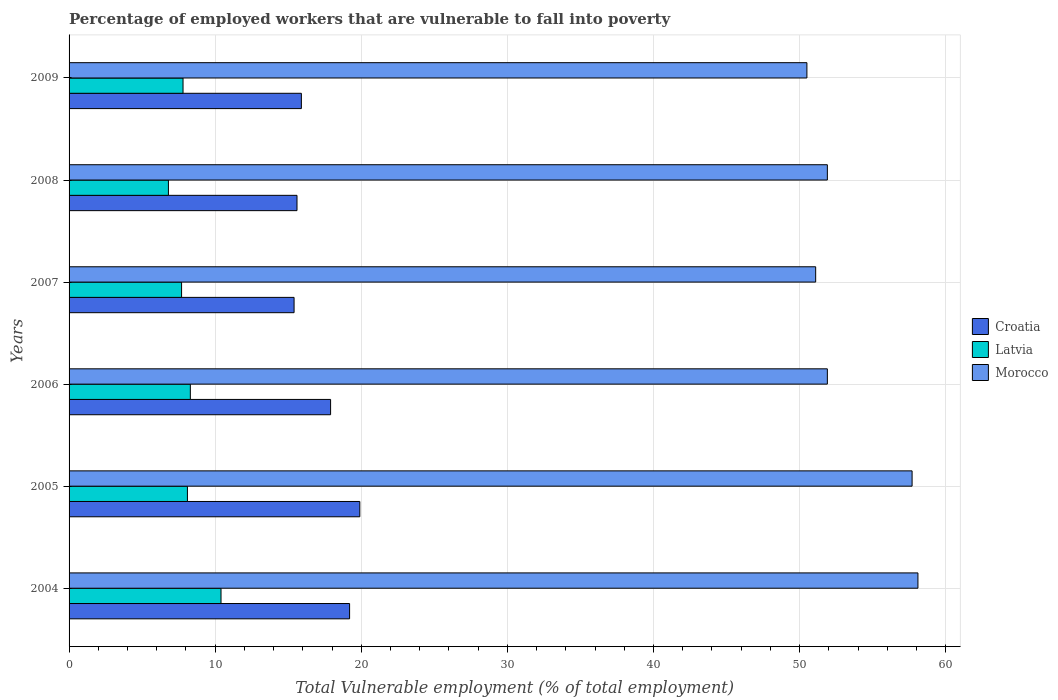Are the number of bars per tick equal to the number of legend labels?
Your response must be concise. Yes. Are the number of bars on each tick of the Y-axis equal?
Your answer should be compact. Yes. How many bars are there on the 4th tick from the top?
Offer a terse response. 3. How many bars are there on the 2nd tick from the bottom?
Make the answer very short. 3. What is the percentage of employed workers who are vulnerable to fall into poverty in Croatia in 2005?
Your answer should be compact. 19.9. Across all years, what is the maximum percentage of employed workers who are vulnerable to fall into poverty in Latvia?
Your answer should be compact. 10.4. Across all years, what is the minimum percentage of employed workers who are vulnerable to fall into poverty in Latvia?
Your response must be concise. 6.8. In which year was the percentage of employed workers who are vulnerable to fall into poverty in Morocco maximum?
Your answer should be compact. 2004. What is the total percentage of employed workers who are vulnerable to fall into poverty in Latvia in the graph?
Give a very brief answer. 49.1. What is the difference between the percentage of employed workers who are vulnerable to fall into poverty in Morocco in 2006 and that in 2007?
Offer a very short reply. 0.8. What is the difference between the percentage of employed workers who are vulnerable to fall into poverty in Croatia in 2004 and the percentage of employed workers who are vulnerable to fall into poverty in Latvia in 2005?
Provide a short and direct response. 11.1. What is the average percentage of employed workers who are vulnerable to fall into poverty in Latvia per year?
Provide a short and direct response. 8.18. In the year 2006, what is the difference between the percentage of employed workers who are vulnerable to fall into poverty in Croatia and percentage of employed workers who are vulnerable to fall into poverty in Latvia?
Give a very brief answer. 9.6. What is the ratio of the percentage of employed workers who are vulnerable to fall into poverty in Latvia in 2004 to that in 2006?
Give a very brief answer. 1.25. Is the difference between the percentage of employed workers who are vulnerable to fall into poverty in Croatia in 2006 and 2008 greater than the difference between the percentage of employed workers who are vulnerable to fall into poverty in Latvia in 2006 and 2008?
Your answer should be compact. Yes. What is the difference between the highest and the second highest percentage of employed workers who are vulnerable to fall into poverty in Latvia?
Offer a terse response. 2.1. What is the difference between the highest and the lowest percentage of employed workers who are vulnerable to fall into poverty in Morocco?
Offer a very short reply. 7.6. In how many years, is the percentage of employed workers who are vulnerable to fall into poverty in Latvia greater than the average percentage of employed workers who are vulnerable to fall into poverty in Latvia taken over all years?
Give a very brief answer. 2. What does the 2nd bar from the top in 2005 represents?
Keep it short and to the point. Latvia. What does the 2nd bar from the bottom in 2006 represents?
Your answer should be compact. Latvia. Is it the case that in every year, the sum of the percentage of employed workers who are vulnerable to fall into poverty in Latvia and percentage of employed workers who are vulnerable to fall into poverty in Morocco is greater than the percentage of employed workers who are vulnerable to fall into poverty in Croatia?
Your answer should be very brief. Yes. How many bars are there?
Offer a very short reply. 18. Are all the bars in the graph horizontal?
Provide a succinct answer. Yes. Are the values on the major ticks of X-axis written in scientific E-notation?
Give a very brief answer. No. How are the legend labels stacked?
Ensure brevity in your answer.  Vertical. What is the title of the graph?
Keep it short and to the point. Percentage of employed workers that are vulnerable to fall into poverty. Does "East Asia (all income levels)" appear as one of the legend labels in the graph?
Your answer should be compact. No. What is the label or title of the X-axis?
Provide a succinct answer. Total Vulnerable employment (% of total employment). What is the label or title of the Y-axis?
Provide a succinct answer. Years. What is the Total Vulnerable employment (% of total employment) of Croatia in 2004?
Offer a terse response. 19.2. What is the Total Vulnerable employment (% of total employment) of Latvia in 2004?
Give a very brief answer. 10.4. What is the Total Vulnerable employment (% of total employment) of Morocco in 2004?
Keep it short and to the point. 58.1. What is the Total Vulnerable employment (% of total employment) of Croatia in 2005?
Your answer should be very brief. 19.9. What is the Total Vulnerable employment (% of total employment) in Latvia in 2005?
Offer a very short reply. 8.1. What is the Total Vulnerable employment (% of total employment) of Morocco in 2005?
Offer a very short reply. 57.7. What is the Total Vulnerable employment (% of total employment) of Croatia in 2006?
Keep it short and to the point. 17.9. What is the Total Vulnerable employment (% of total employment) of Latvia in 2006?
Your answer should be very brief. 8.3. What is the Total Vulnerable employment (% of total employment) of Morocco in 2006?
Provide a short and direct response. 51.9. What is the Total Vulnerable employment (% of total employment) in Croatia in 2007?
Give a very brief answer. 15.4. What is the Total Vulnerable employment (% of total employment) in Latvia in 2007?
Offer a very short reply. 7.7. What is the Total Vulnerable employment (% of total employment) in Morocco in 2007?
Ensure brevity in your answer.  51.1. What is the Total Vulnerable employment (% of total employment) of Croatia in 2008?
Provide a succinct answer. 15.6. What is the Total Vulnerable employment (% of total employment) of Latvia in 2008?
Offer a very short reply. 6.8. What is the Total Vulnerable employment (% of total employment) of Morocco in 2008?
Give a very brief answer. 51.9. What is the Total Vulnerable employment (% of total employment) in Croatia in 2009?
Your answer should be very brief. 15.9. What is the Total Vulnerable employment (% of total employment) of Latvia in 2009?
Offer a very short reply. 7.8. What is the Total Vulnerable employment (% of total employment) of Morocco in 2009?
Give a very brief answer. 50.5. Across all years, what is the maximum Total Vulnerable employment (% of total employment) in Croatia?
Keep it short and to the point. 19.9. Across all years, what is the maximum Total Vulnerable employment (% of total employment) of Latvia?
Keep it short and to the point. 10.4. Across all years, what is the maximum Total Vulnerable employment (% of total employment) of Morocco?
Your answer should be very brief. 58.1. Across all years, what is the minimum Total Vulnerable employment (% of total employment) of Croatia?
Your answer should be very brief. 15.4. Across all years, what is the minimum Total Vulnerable employment (% of total employment) of Latvia?
Make the answer very short. 6.8. Across all years, what is the minimum Total Vulnerable employment (% of total employment) in Morocco?
Provide a succinct answer. 50.5. What is the total Total Vulnerable employment (% of total employment) of Croatia in the graph?
Provide a short and direct response. 103.9. What is the total Total Vulnerable employment (% of total employment) in Latvia in the graph?
Your answer should be compact. 49.1. What is the total Total Vulnerable employment (% of total employment) of Morocco in the graph?
Your response must be concise. 321.2. What is the difference between the Total Vulnerable employment (% of total employment) of Latvia in 2004 and that in 2005?
Offer a very short reply. 2.3. What is the difference between the Total Vulnerable employment (% of total employment) in Croatia in 2004 and that in 2006?
Give a very brief answer. 1.3. What is the difference between the Total Vulnerable employment (% of total employment) in Morocco in 2004 and that in 2006?
Offer a terse response. 6.2. What is the difference between the Total Vulnerable employment (% of total employment) of Croatia in 2004 and that in 2007?
Your response must be concise. 3.8. What is the difference between the Total Vulnerable employment (% of total employment) in Latvia in 2004 and that in 2007?
Make the answer very short. 2.7. What is the difference between the Total Vulnerable employment (% of total employment) in Morocco in 2004 and that in 2007?
Provide a short and direct response. 7. What is the difference between the Total Vulnerable employment (% of total employment) of Latvia in 2004 and that in 2009?
Ensure brevity in your answer.  2.6. What is the difference between the Total Vulnerable employment (% of total employment) in Morocco in 2004 and that in 2009?
Your answer should be very brief. 7.6. What is the difference between the Total Vulnerable employment (% of total employment) of Croatia in 2005 and that in 2006?
Your response must be concise. 2. What is the difference between the Total Vulnerable employment (% of total employment) in Latvia in 2005 and that in 2006?
Your answer should be very brief. -0.2. What is the difference between the Total Vulnerable employment (% of total employment) in Croatia in 2005 and that in 2007?
Your answer should be compact. 4.5. What is the difference between the Total Vulnerable employment (% of total employment) in Latvia in 2005 and that in 2007?
Give a very brief answer. 0.4. What is the difference between the Total Vulnerable employment (% of total employment) of Morocco in 2005 and that in 2007?
Ensure brevity in your answer.  6.6. What is the difference between the Total Vulnerable employment (% of total employment) in Croatia in 2005 and that in 2009?
Ensure brevity in your answer.  4. What is the difference between the Total Vulnerable employment (% of total employment) of Morocco in 2005 and that in 2009?
Offer a terse response. 7.2. What is the difference between the Total Vulnerable employment (% of total employment) in Morocco in 2006 and that in 2007?
Give a very brief answer. 0.8. What is the difference between the Total Vulnerable employment (% of total employment) in Croatia in 2006 and that in 2008?
Your response must be concise. 2.3. What is the difference between the Total Vulnerable employment (% of total employment) of Morocco in 2006 and that in 2008?
Offer a very short reply. 0. What is the difference between the Total Vulnerable employment (% of total employment) in Croatia in 2006 and that in 2009?
Your answer should be very brief. 2. What is the difference between the Total Vulnerable employment (% of total employment) in Latvia in 2006 and that in 2009?
Keep it short and to the point. 0.5. What is the difference between the Total Vulnerable employment (% of total employment) of Croatia in 2007 and that in 2008?
Your answer should be very brief. -0.2. What is the difference between the Total Vulnerable employment (% of total employment) of Morocco in 2007 and that in 2008?
Provide a short and direct response. -0.8. What is the difference between the Total Vulnerable employment (% of total employment) of Croatia in 2007 and that in 2009?
Your answer should be very brief. -0.5. What is the difference between the Total Vulnerable employment (% of total employment) in Latvia in 2007 and that in 2009?
Your response must be concise. -0.1. What is the difference between the Total Vulnerable employment (% of total employment) in Latvia in 2008 and that in 2009?
Offer a terse response. -1. What is the difference between the Total Vulnerable employment (% of total employment) in Croatia in 2004 and the Total Vulnerable employment (% of total employment) in Morocco in 2005?
Your response must be concise. -38.5. What is the difference between the Total Vulnerable employment (% of total employment) of Latvia in 2004 and the Total Vulnerable employment (% of total employment) of Morocco in 2005?
Keep it short and to the point. -47.3. What is the difference between the Total Vulnerable employment (% of total employment) in Croatia in 2004 and the Total Vulnerable employment (% of total employment) in Latvia in 2006?
Provide a short and direct response. 10.9. What is the difference between the Total Vulnerable employment (% of total employment) in Croatia in 2004 and the Total Vulnerable employment (% of total employment) in Morocco in 2006?
Provide a short and direct response. -32.7. What is the difference between the Total Vulnerable employment (% of total employment) of Latvia in 2004 and the Total Vulnerable employment (% of total employment) of Morocco in 2006?
Give a very brief answer. -41.5. What is the difference between the Total Vulnerable employment (% of total employment) in Croatia in 2004 and the Total Vulnerable employment (% of total employment) in Latvia in 2007?
Make the answer very short. 11.5. What is the difference between the Total Vulnerable employment (% of total employment) of Croatia in 2004 and the Total Vulnerable employment (% of total employment) of Morocco in 2007?
Make the answer very short. -31.9. What is the difference between the Total Vulnerable employment (% of total employment) in Latvia in 2004 and the Total Vulnerable employment (% of total employment) in Morocco in 2007?
Ensure brevity in your answer.  -40.7. What is the difference between the Total Vulnerable employment (% of total employment) of Croatia in 2004 and the Total Vulnerable employment (% of total employment) of Morocco in 2008?
Your response must be concise. -32.7. What is the difference between the Total Vulnerable employment (% of total employment) in Latvia in 2004 and the Total Vulnerable employment (% of total employment) in Morocco in 2008?
Make the answer very short. -41.5. What is the difference between the Total Vulnerable employment (% of total employment) of Croatia in 2004 and the Total Vulnerable employment (% of total employment) of Latvia in 2009?
Your answer should be very brief. 11.4. What is the difference between the Total Vulnerable employment (% of total employment) of Croatia in 2004 and the Total Vulnerable employment (% of total employment) of Morocco in 2009?
Make the answer very short. -31.3. What is the difference between the Total Vulnerable employment (% of total employment) of Latvia in 2004 and the Total Vulnerable employment (% of total employment) of Morocco in 2009?
Ensure brevity in your answer.  -40.1. What is the difference between the Total Vulnerable employment (% of total employment) of Croatia in 2005 and the Total Vulnerable employment (% of total employment) of Latvia in 2006?
Offer a terse response. 11.6. What is the difference between the Total Vulnerable employment (% of total employment) of Croatia in 2005 and the Total Vulnerable employment (% of total employment) of Morocco in 2006?
Provide a succinct answer. -32. What is the difference between the Total Vulnerable employment (% of total employment) of Latvia in 2005 and the Total Vulnerable employment (% of total employment) of Morocco in 2006?
Make the answer very short. -43.8. What is the difference between the Total Vulnerable employment (% of total employment) of Croatia in 2005 and the Total Vulnerable employment (% of total employment) of Latvia in 2007?
Provide a short and direct response. 12.2. What is the difference between the Total Vulnerable employment (% of total employment) in Croatia in 2005 and the Total Vulnerable employment (% of total employment) in Morocco in 2007?
Ensure brevity in your answer.  -31.2. What is the difference between the Total Vulnerable employment (% of total employment) in Latvia in 2005 and the Total Vulnerable employment (% of total employment) in Morocco in 2007?
Your answer should be compact. -43. What is the difference between the Total Vulnerable employment (% of total employment) in Croatia in 2005 and the Total Vulnerable employment (% of total employment) in Morocco in 2008?
Keep it short and to the point. -32. What is the difference between the Total Vulnerable employment (% of total employment) of Latvia in 2005 and the Total Vulnerable employment (% of total employment) of Morocco in 2008?
Your answer should be very brief. -43.8. What is the difference between the Total Vulnerable employment (% of total employment) in Croatia in 2005 and the Total Vulnerable employment (% of total employment) in Latvia in 2009?
Offer a terse response. 12.1. What is the difference between the Total Vulnerable employment (% of total employment) in Croatia in 2005 and the Total Vulnerable employment (% of total employment) in Morocco in 2009?
Keep it short and to the point. -30.6. What is the difference between the Total Vulnerable employment (% of total employment) of Latvia in 2005 and the Total Vulnerable employment (% of total employment) of Morocco in 2009?
Offer a very short reply. -42.4. What is the difference between the Total Vulnerable employment (% of total employment) in Croatia in 2006 and the Total Vulnerable employment (% of total employment) in Morocco in 2007?
Offer a very short reply. -33.2. What is the difference between the Total Vulnerable employment (% of total employment) of Latvia in 2006 and the Total Vulnerable employment (% of total employment) of Morocco in 2007?
Your answer should be very brief. -42.8. What is the difference between the Total Vulnerable employment (% of total employment) in Croatia in 2006 and the Total Vulnerable employment (% of total employment) in Latvia in 2008?
Offer a terse response. 11.1. What is the difference between the Total Vulnerable employment (% of total employment) of Croatia in 2006 and the Total Vulnerable employment (% of total employment) of Morocco in 2008?
Your answer should be very brief. -34. What is the difference between the Total Vulnerable employment (% of total employment) in Latvia in 2006 and the Total Vulnerable employment (% of total employment) in Morocco in 2008?
Provide a short and direct response. -43.6. What is the difference between the Total Vulnerable employment (% of total employment) in Croatia in 2006 and the Total Vulnerable employment (% of total employment) in Latvia in 2009?
Make the answer very short. 10.1. What is the difference between the Total Vulnerable employment (% of total employment) of Croatia in 2006 and the Total Vulnerable employment (% of total employment) of Morocco in 2009?
Your answer should be very brief. -32.6. What is the difference between the Total Vulnerable employment (% of total employment) in Latvia in 2006 and the Total Vulnerable employment (% of total employment) in Morocco in 2009?
Give a very brief answer. -42.2. What is the difference between the Total Vulnerable employment (% of total employment) in Croatia in 2007 and the Total Vulnerable employment (% of total employment) in Latvia in 2008?
Your response must be concise. 8.6. What is the difference between the Total Vulnerable employment (% of total employment) of Croatia in 2007 and the Total Vulnerable employment (% of total employment) of Morocco in 2008?
Give a very brief answer. -36.5. What is the difference between the Total Vulnerable employment (% of total employment) of Latvia in 2007 and the Total Vulnerable employment (% of total employment) of Morocco in 2008?
Make the answer very short. -44.2. What is the difference between the Total Vulnerable employment (% of total employment) of Croatia in 2007 and the Total Vulnerable employment (% of total employment) of Morocco in 2009?
Your response must be concise. -35.1. What is the difference between the Total Vulnerable employment (% of total employment) in Latvia in 2007 and the Total Vulnerable employment (% of total employment) in Morocco in 2009?
Your answer should be very brief. -42.8. What is the difference between the Total Vulnerable employment (% of total employment) of Croatia in 2008 and the Total Vulnerable employment (% of total employment) of Morocco in 2009?
Give a very brief answer. -34.9. What is the difference between the Total Vulnerable employment (% of total employment) of Latvia in 2008 and the Total Vulnerable employment (% of total employment) of Morocco in 2009?
Ensure brevity in your answer.  -43.7. What is the average Total Vulnerable employment (% of total employment) in Croatia per year?
Your answer should be very brief. 17.32. What is the average Total Vulnerable employment (% of total employment) in Latvia per year?
Make the answer very short. 8.18. What is the average Total Vulnerable employment (% of total employment) of Morocco per year?
Provide a short and direct response. 53.53. In the year 2004, what is the difference between the Total Vulnerable employment (% of total employment) in Croatia and Total Vulnerable employment (% of total employment) in Latvia?
Give a very brief answer. 8.8. In the year 2004, what is the difference between the Total Vulnerable employment (% of total employment) of Croatia and Total Vulnerable employment (% of total employment) of Morocco?
Your answer should be compact. -38.9. In the year 2004, what is the difference between the Total Vulnerable employment (% of total employment) in Latvia and Total Vulnerable employment (% of total employment) in Morocco?
Your answer should be compact. -47.7. In the year 2005, what is the difference between the Total Vulnerable employment (% of total employment) of Croatia and Total Vulnerable employment (% of total employment) of Latvia?
Your answer should be very brief. 11.8. In the year 2005, what is the difference between the Total Vulnerable employment (% of total employment) of Croatia and Total Vulnerable employment (% of total employment) of Morocco?
Your response must be concise. -37.8. In the year 2005, what is the difference between the Total Vulnerable employment (% of total employment) in Latvia and Total Vulnerable employment (% of total employment) in Morocco?
Ensure brevity in your answer.  -49.6. In the year 2006, what is the difference between the Total Vulnerable employment (% of total employment) in Croatia and Total Vulnerable employment (% of total employment) in Latvia?
Offer a very short reply. 9.6. In the year 2006, what is the difference between the Total Vulnerable employment (% of total employment) of Croatia and Total Vulnerable employment (% of total employment) of Morocco?
Give a very brief answer. -34. In the year 2006, what is the difference between the Total Vulnerable employment (% of total employment) of Latvia and Total Vulnerable employment (% of total employment) of Morocco?
Ensure brevity in your answer.  -43.6. In the year 2007, what is the difference between the Total Vulnerable employment (% of total employment) of Croatia and Total Vulnerable employment (% of total employment) of Morocco?
Give a very brief answer. -35.7. In the year 2007, what is the difference between the Total Vulnerable employment (% of total employment) of Latvia and Total Vulnerable employment (% of total employment) of Morocco?
Provide a succinct answer. -43.4. In the year 2008, what is the difference between the Total Vulnerable employment (% of total employment) in Croatia and Total Vulnerable employment (% of total employment) in Latvia?
Your answer should be very brief. 8.8. In the year 2008, what is the difference between the Total Vulnerable employment (% of total employment) in Croatia and Total Vulnerable employment (% of total employment) in Morocco?
Ensure brevity in your answer.  -36.3. In the year 2008, what is the difference between the Total Vulnerable employment (% of total employment) of Latvia and Total Vulnerable employment (% of total employment) of Morocco?
Your answer should be very brief. -45.1. In the year 2009, what is the difference between the Total Vulnerable employment (% of total employment) in Croatia and Total Vulnerable employment (% of total employment) in Latvia?
Provide a short and direct response. 8.1. In the year 2009, what is the difference between the Total Vulnerable employment (% of total employment) of Croatia and Total Vulnerable employment (% of total employment) of Morocco?
Keep it short and to the point. -34.6. In the year 2009, what is the difference between the Total Vulnerable employment (% of total employment) in Latvia and Total Vulnerable employment (% of total employment) in Morocco?
Offer a terse response. -42.7. What is the ratio of the Total Vulnerable employment (% of total employment) in Croatia in 2004 to that in 2005?
Provide a succinct answer. 0.96. What is the ratio of the Total Vulnerable employment (% of total employment) of Latvia in 2004 to that in 2005?
Provide a succinct answer. 1.28. What is the ratio of the Total Vulnerable employment (% of total employment) in Morocco in 2004 to that in 2005?
Provide a succinct answer. 1.01. What is the ratio of the Total Vulnerable employment (% of total employment) of Croatia in 2004 to that in 2006?
Ensure brevity in your answer.  1.07. What is the ratio of the Total Vulnerable employment (% of total employment) of Latvia in 2004 to that in 2006?
Offer a very short reply. 1.25. What is the ratio of the Total Vulnerable employment (% of total employment) in Morocco in 2004 to that in 2006?
Offer a very short reply. 1.12. What is the ratio of the Total Vulnerable employment (% of total employment) of Croatia in 2004 to that in 2007?
Keep it short and to the point. 1.25. What is the ratio of the Total Vulnerable employment (% of total employment) in Latvia in 2004 to that in 2007?
Your answer should be compact. 1.35. What is the ratio of the Total Vulnerable employment (% of total employment) of Morocco in 2004 to that in 2007?
Keep it short and to the point. 1.14. What is the ratio of the Total Vulnerable employment (% of total employment) of Croatia in 2004 to that in 2008?
Offer a very short reply. 1.23. What is the ratio of the Total Vulnerable employment (% of total employment) of Latvia in 2004 to that in 2008?
Make the answer very short. 1.53. What is the ratio of the Total Vulnerable employment (% of total employment) of Morocco in 2004 to that in 2008?
Give a very brief answer. 1.12. What is the ratio of the Total Vulnerable employment (% of total employment) of Croatia in 2004 to that in 2009?
Offer a very short reply. 1.21. What is the ratio of the Total Vulnerable employment (% of total employment) of Morocco in 2004 to that in 2009?
Offer a very short reply. 1.15. What is the ratio of the Total Vulnerable employment (% of total employment) in Croatia in 2005 to that in 2006?
Offer a very short reply. 1.11. What is the ratio of the Total Vulnerable employment (% of total employment) in Latvia in 2005 to that in 2006?
Provide a short and direct response. 0.98. What is the ratio of the Total Vulnerable employment (% of total employment) in Morocco in 2005 to that in 2006?
Offer a terse response. 1.11. What is the ratio of the Total Vulnerable employment (% of total employment) in Croatia in 2005 to that in 2007?
Ensure brevity in your answer.  1.29. What is the ratio of the Total Vulnerable employment (% of total employment) in Latvia in 2005 to that in 2007?
Ensure brevity in your answer.  1.05. What is the ratio of the Total Vulnerable employment (% of total employment) of Morocco in 2005 to that in 2007?
Provide a succinct answer. 1.13. What is the ratio of the Total Vulnerable employment (% of total employment) of Croatia in 2005 to that in 2008?
Your response must be concise. 1.28. What is the ratio of the Total Vulnerable employment (% of total employment) in Latvia in 2005 to that in 2008?
Ensure brevity in your answer.  1.19. What is the ratio of the Total Vulnerable employment (% of total employment) in Morocco in 2005 to that in 2008?
Give a very brief answer. 1.11. What is the ratio of the Total Vulnerable employment (% of total employment) in Croatia in 2005 to that in 2009?
Your response must be concise. 1.25. What is the ratio of the Total Vulnerable employment (% of total employment) of Latvia in 2005 to that in 2009?
Your response must be concise. 1.04. What is the ratio of the Total Vulnerable employment (% of total employment) in Morocco in 2005 to that in 2009?
Keep it short and to the point. 1.14. What is the ratio of the Total Vulnerable employment (% of total employment) in Croatia in 2006 to that in 2007?
Your answer should be compact. 1.16. What is the ratio of the Total Vulnerable employment (% of total employment) in Latvia in 2006 to that in 2007?
Provide a short and direct response. 1.08. What is the ratio of the Total Vulnerable employment (% of total employment) of Morocco in 2006 to that in 2007?
Your answer should be compact. 1.02. What is the ratio of the Total Vulnerable employment (% of total employment) in Croatia in 2006 to that in 2008?
Your answer should be compact. 1.15. What is the ratio of the Total Vulnerable employment (% of total employment) in Latvia in 2006 to that in 2008?
Your answer should be compact. 1.22. What is the ratio of the Total Vulnerable employment (% of total employment) of Morocco in 2006 to that in 2008?
Offer a very short reply. 1. What is the ratio of the Total Vulnerable employment (% of total employment) of Croatia in 2006 to that in 2009?
Your answer should be compact. 1.13. What is the ratio of the Total Vulnerable employment (% of total employment) of Latvia in 2006 to that in 2009?
Provide a succinct answer. 1.06. What is the ratio of the Total Vulnerable employment (% of total employment) in Morocco in 2006 to that in 2009?
Ensure brevity in your answer.  1.03. What is the ratio of the Total Vulnerable employment (% of total employment) of Croatia in 2007 to that in 2008?
Keep it short and to the point. 0.99. What is the ratio of the Total Vulnerable employment (% of total employment) in Latvia in 2007 to that in 2008?
Make the answer very short. 1.13. What is the ratio of the Total Vulnerable employment (% of total employment) in Morocco in 2007 to that in 2008?
Ensure brevity in your answer.  0.98. What is the ratio of the Total Vulnerable employment (% of total employment) of Croatia in 2007 to that in 2009?
Make the answer very short. 0.97. What is the ratio of the Total Vulnerable employment (% of total employment) of Latvia in 2007 to that in 2009?
Ensure brevity in your answer.  0.99. What is the ratio of the Total Vulnerable employment (% of total employment) of Morocco in 2007 to that in 2009?
Your answer should be very brief. 1.01. What is the ratio of the Total Vulnerable employment (% of total employment) in Croatia in 2008 to that in 2009?
Provide a succinct answer. 0.98. What is the ratio of the Total Vulnerable employment (% of total employment) in Latvia in 2008 to that in 2009?
Ensure brevity in your answer.  0.87. What is the ratio of the Total Vulnerable employment (% of total employment) of Morocco in 2008 to that in 2009?
Keep it short and to the point. 1.03. What is the difference between the highest and the second highest Total Vulnerable employment (% of total employment) in Croatia?
Provide a short and direct response. 0.7. What is the difference between the highest and the second highest Total Vulnerable employment (% of total employment) in Morocco?
Provide a short and direct response. 0.4. What is the difference between the highest and the lowest Total Vulnerable employment (% of total employment) in Croatia?
Your response must be concise. 4.5. What is the difference between the highest and the lowest Total Vulnerable employment (% of total employment) in Latvia?
Give a very brief answer. 3.6. What is the difference between the highest and the lowest Total Vulnerable employment (% of total employment) in Morocco?
Offer a terse response. 7.6. 